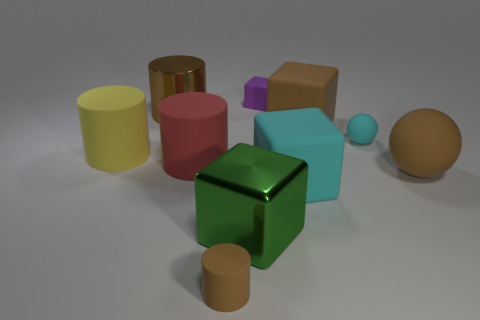What material is the purple thing?
Give a very brief answer. Rubber. How many big objects are cyan rubber blocks or purple rubber cubes?
Keep it short and to the point. 1. How many big matte spheres are in front of the brown metal object?
Your response must be concise. 1. Is there a ball that has the same color as the small cylinder?
Your response must be concise. Yes. What is the shape of the brown metal thing that is the same size as the red matte thing?
Your response must be concise. Cylinder. How many cyan things are either tiny rubber cylinders or blocks?
Offer a terse response. 1. How many green rubber cylinders are the same size as the brown cube?
Your answer should be compact. 0. What shape is the large metallic thing that is the same color as the large matte ball?
Your answer should be compact. Cylinder. What number of objects are large red matte cylinders or green metallic objects in front of the large matte sphere?
Provide a succinct answer. 2. There is a cyan thing behind the red matte thing; does it have the same size as the thing that is right of the small cyan thing?
Your response must be concise. No. 